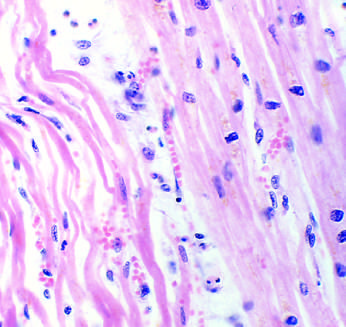what are separated by edema fluid?
Answer the question using a single word or phrase. Necrotic cells 